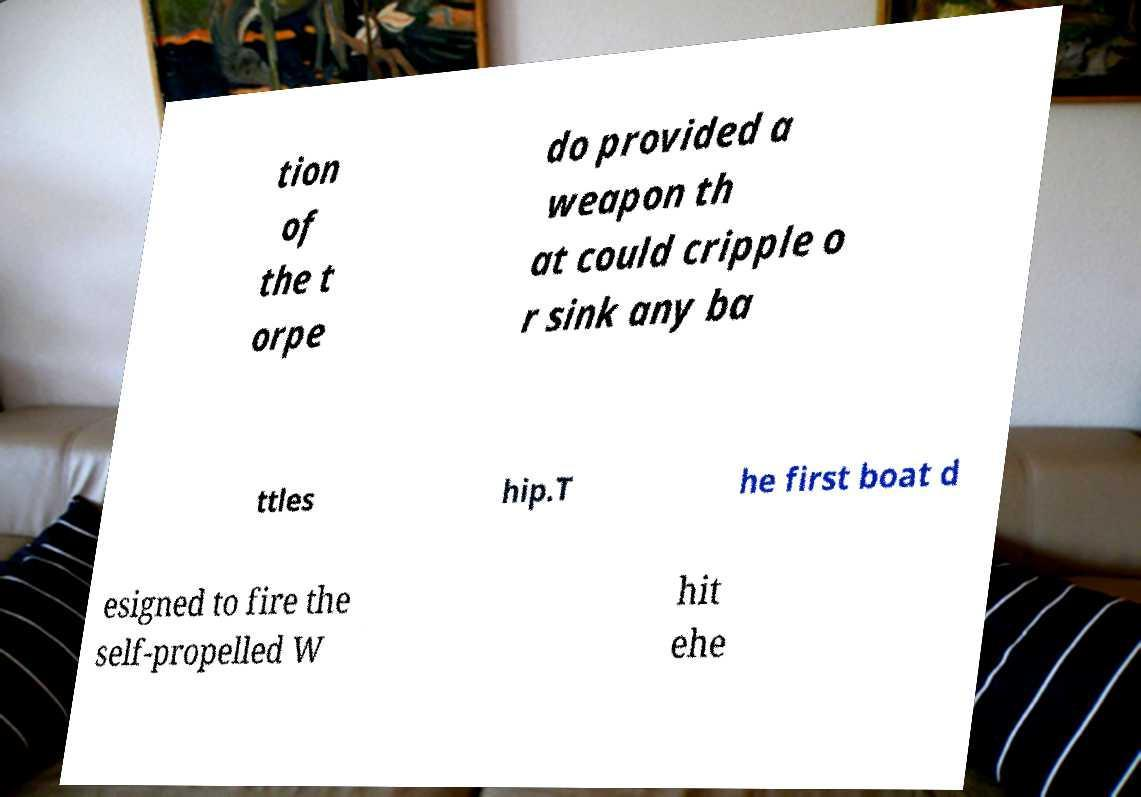There's text embedded in this image that I need extracted. Can you transcribe it verbatim? tion of the t orpe do provided a weapon th at could cripple o r sink any ba ttles hip.T he first boat d esigned to fire the self-propelled W hit ehe 